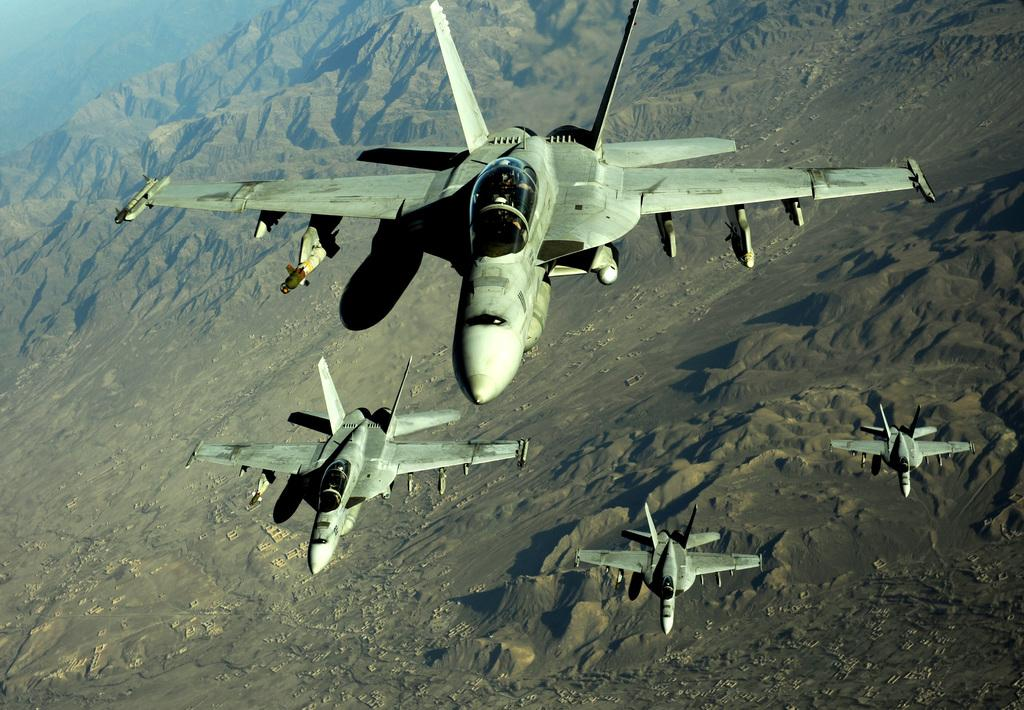What is the main subject of the image? The main subject of the image is aircrafts, which are located in the center of the image. What can be seen in the background of the image? In the background of the image, there are mountains and sand visible. What type of corn is being harvested in the image? There is no corn present in the image; it features aircrafts and a background with mountains and sand. 